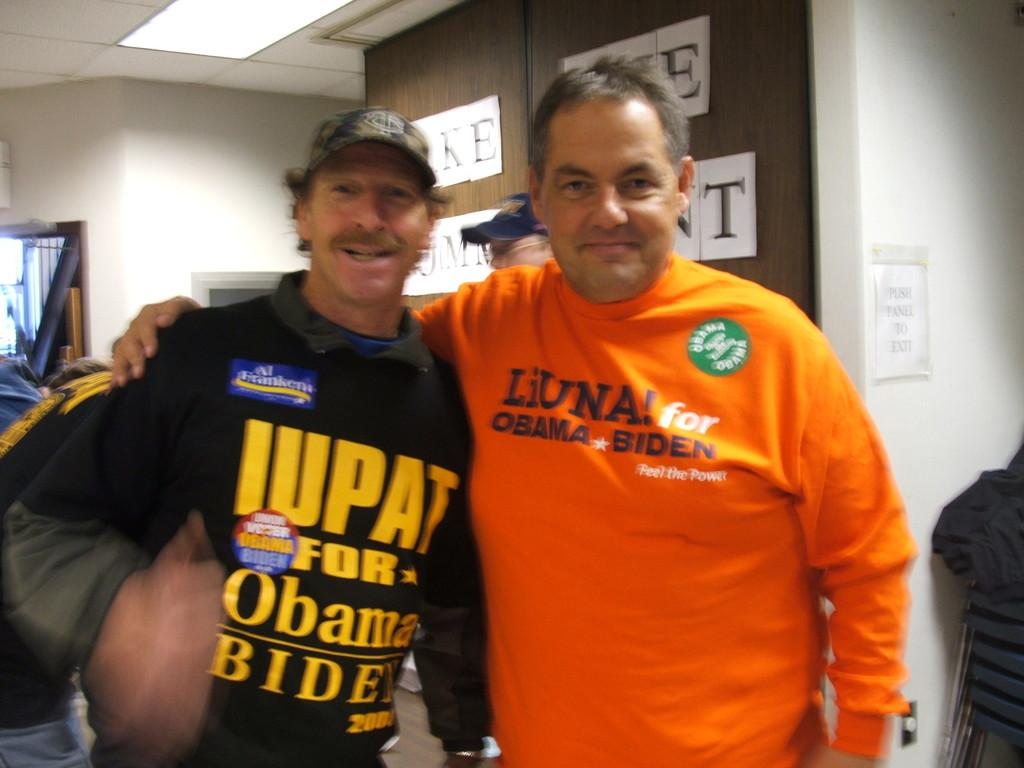<image>
Relay a brief, clear account of the picture shown. Two men are wearing shirts that have Obama and Biden on the front. 